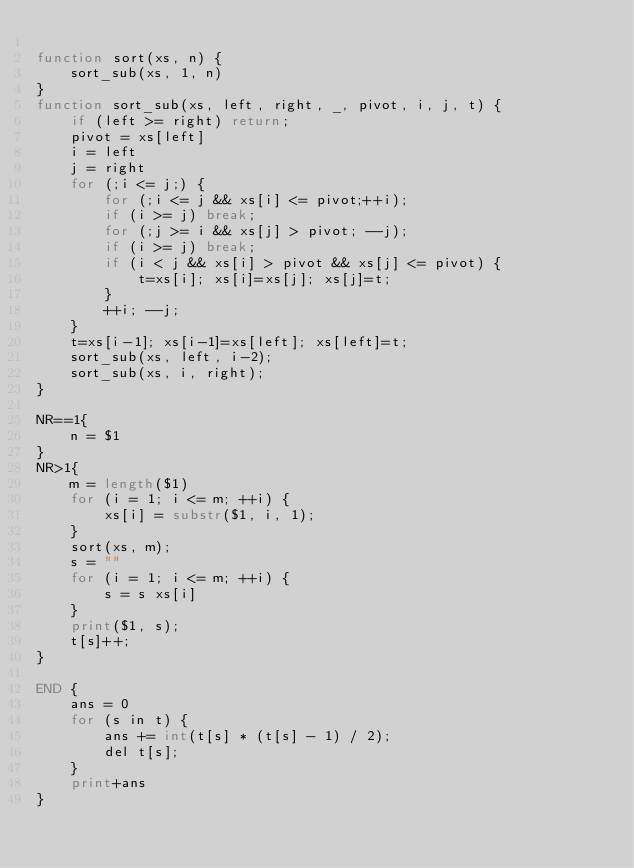Convert code to text. <code><loc_0><loc_0><loc_500><loc_500><_Awk_>
function sort(xs, n) {
    sort_sub(xs, 1, n)
}
function sort_sub(xs, left, right, _, pivot, i, j, t) {
    if (left >= right) return;
    pivot = xs[left]
    i = left
    j = right
    for (;i <= j;) {
        for (;i <= j && xs[i] <= pivot;++i);
        if (i >= j) break;
        for (;j >= i && xs[j] > pivot; --j);
        if (i >= j) break;
        if (i < j && xs[i] > pivot && xs[j] <= pivot) {
            t=xs[i]; xs[i]=xs[j]; xs[j]=t;
        }
        ++i; --j;
    }
    t=xs[i-1]; xs[i-1]=xs[left]; xs[left]=t;
    sort_sub(xs, left, i-2);
    sort_sub(xs, i, right);
}

NR==1{
    n = $1
}
NR>1{
    m = length($1)
    for (i = 1; i <= m; ++i) {
        xs[i] = substr($1, i, 1);
    }
    sort(xs, m);
    s = ""
    for (i = 1; i <= m; ++i) {
        s = s xs[i]
    }
    print($1, s);
    t[s]++;
}

END {
    ans = 0
    for (s in t) {
        ans += int(t[s] * (t[s] - 1) / 2);
        del t[s];
    }
    print+ans
}
</code> 